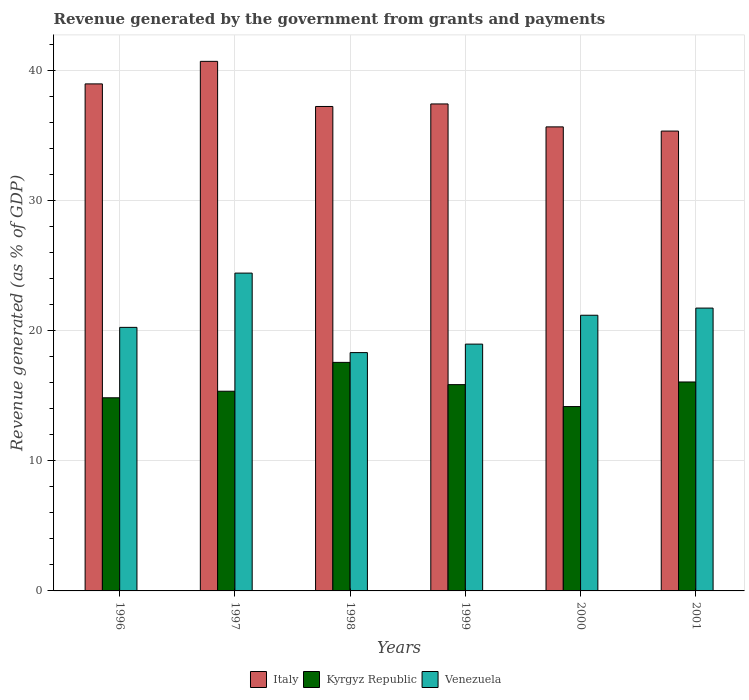How many groups of bars are there?
Your answer should be compact. 6. Are the number of bars per tick equal to the number of legend labels?
Give a very brief answer. Yes. Are the number of bars on each tick of the X-axis equal?
Keep it short and to the point. Yes. How many bars are there on the 3rd tick from the left?
Your response must be concise. 3. How many bars are there on the 4th tick from the right?
Keep it short and to the point. 3. In how many cases, is the number of bars for a given year not equal to the number of legend labels?
Your answer should be compact. 0. What is the revenue generated by the government in Venezuela in 1999?
Your answer should be compact. 18.96. Across all years, what is the maximum revenue generated by the government in Kyrgyz Republic?
Give a very brief answer. 17.56. Across all years, what is the minimum revenue generated by the government in Venezuela?
Your answer should be compact. 18.31. In which year was the revenue generated by the government in Kyrgyz Republic maximum?
Your answer should be compact. 1998. In which year was the revenue generated by the government in Italy minimum?
Offer a terse response. 2001. What is the total revenue generated by the government in Italy in the graph?
Give a very brief answer. 225.24. What is the difference between the revenue generated by the government in Venezuela in 2000 and that in 2001?
Make the answer very short. -0.55. What is the difference between the revenue generated by the government in Venezuela in 2000 and the revenue generated by the government in Italy in 1997?
Your response must be concise. -19.51. What is the average revenue generated by the government in Italy per year?
Provide a short and direct response. 37.54. In the year 2001, what is the difference between the revenue generated by the government in Kyrgyz Republic and revenue generated by the government in Venezuela?
Offer a terse response. -5.68. In how many years, is the revenue generated by the government in Venezuela greater than 6 %?
Give a very brief answer. 6. What is the ratio of the revenue generated by the government in Venezuela in 1997 to that in 2001?
Offer a terse response. 1.12. Is the revenue generated by the government in Venezuela in 1999 less than that in 2000?
Make the answer very short. Yes. Is the difference between the revenue generated by the government in Kyrgyz Republic in 1999 and 2001 greater than the difference between the revenue generated by the government in Venezuela in 1999 and 2001?
Keep it short and to the point. Yes. What is the difference between the highest and the second highest revenue generated by the government in Venezuela?
Give a very brief answer. 2.69. What is the difference between the highest and the lowest revenue generated by the government in Venezuela?
Make the answer very short. 6.11. In how many years, is the revenue generated by the government in Kyrgyz Republic greater than the average revenue generated by the government in Kyrgyz Republic taken over all years?
Provide a succinct answer. 3. What does the 3rd bar from the left in 2001 represents?
Your answer should be very brief. Venezuela. What does the 3rd bar from the right in 1996 represents?
Make the answer very short. Italy. Is it the case that in every year, the sum of the revenue generated by the government in Venezuela and revenue generated by the government in Kyrgyz Republic is greater than the revenue generated by the government in Italy?
Your answer should be compact. No. How many bars are there?
Offer a very short reply. 18. Are all the bars in the graph horizontal?
Give a very brief answer. No. How many years are there in the graph?
Offer a terse response. 6. Are the values on the major ticks of Y-axis written in scientific E-notation?
Ensure brevity in your answer.  No. Does the graph contain grids?
Give a very brief answer. Yes. How many legend labels are there?
Keep it short and to the point. 3. What is the title of the graph?
Your response must be concise. Revenue generated by the government from grants and payments. Does "Other small states" appear as one of the legend labels in the graph?
Your response must be concise. No. What is the label or title of the Y-axis?
Provide a succinct answer. Revenue generated (as % of GDP). What is the Revenue generated (as % of GDP) in Italy in 1996?
Keep it short and to the point. 38.95. What is the Revenue generated (as % of GDP) of Kyrgyz Republic in 1996?
Provide a short and direct response. 14.84. What is the Revenue generated (as % of GDP) in Venezuela in 1996?
Ensure brevity in your answer.  20.25. What is the Revenue generated (as % of GDP) of Italy in 1997?
Keep it short and to the point. 40.68. What is the Revenue generated (as % of GDP) in Kyrgyz Republic in 1997?
Provide a succinct answer. 15.34. What is the Revenue generated (as % of GDP) of Venezuela in 1997?
Provide a short and direct response. 24.42. What is the Revenue generated (as % of GDP) of Italy in 1998?
Offer a very short reply. 37.22. What is the Revenue generated (as % of GDP) of Kyrgyz Republic in 1998?
Ensure brevity in your answer.  17.56. What is the Revenue generated (as % of GDP) in Venezuela in 1998?
Offer a terse response. 18.31. What is the Revenue generated (as % of GDP) in Italy in 1999?
Provide a succinct answer. 37.41. What is the Revenue generated (as % of GDP) in Kyrgyz Republic in 1999?
Keep it short and to the point. 15.85. What is the Revenue generated (as % of GDP) of Venezuela in 1999?
Offer a very short reply. 18.96. What is the Revenue generated (as % of GDP) of Italy in 2000?
Give a very brief answer. 35.65. What is the Revenue generated (as % of GDP) in Kyrgyz Republic in 2000?
Your response must be concise. 14.16. What is the Revenue generated (as % of GDP) of Venezuela in 2000?
Provide a short and direct response. 21.18. What is the Revenue generated (as % of GDP) of Italy in 2001?
Make the answer very short. 35.33. What is the Revenue generated (as % of GDP) of Kyrgyz Republic in 2001?
Keep it short and to the point. 16.05. What is the Revenue generated (as % of GDP) of Venezuela in 2001?
Provide a short and direct response. 21.73. Across all years, what is the maximum Revenue generated (as % of GDP) of Italy?
Offer a terse response. 40.68. Across all years, what is the maximum Revenue generated (as % of GDP) of Kyrgyz Republic?
Your response must be concise. 17.56. Across all years, what is the maximum Revenue generated (as % of GDP) in Venezuela?
Ensure brevity in your answer.  24.42. Across all years, what is the minimum Revenue generated (as % of GDP) in Italy?
Offer a terse response. 35.33. Across all years, what is the minimum Revenue generated (as % of GDP) of Kyrgyz Republic?
Offer a terse response. 14.16. Across all years, what is the minimum Revenue generated (as % of GDP) in Venezuela?
Your answer should be compact. 18.31. What is the total Revenue generated (as % of GDP) in Italy in the graph?
Your response must be concise. 225.24. What is the total Revenue generated (as % of GDP) in Kyrgyz Republic in the graph?
Provide a succinct answer. 93.8. What is the total Revenue generated (as % of GDP) of Venezuela in the graph?
Your answer should be compact. 124.84. What is the difference between the Revenue generated (as % of GDP) of Italy in 1996 and that in 1997?
Provide a short and direct response. -1.73. What is the difference between the Revenue generated (as % of GDP) of Kyrgyz Republic in 1996 and that in 1997?
Offer a very short reply. -0.5. What is the difference between the Revenue generated (as % of GDP) of Venezuela in 1996 and that in 1997?
Provide a short and direct response. -4.17. What is the difference between the Revenue generated (as % of GDP) of Italy in 1996 and that in 1998?
Provide a short and direct response. 1.73. What is the difference between the Revenue generated (as % of GDP) in Kyrgyz Republic in 1996 and that in 1998?
Your answer should be very brief. -2.72. What is the difference between the Revenue generated (as % of GDP) in Venezuela in 1996 and that in 1998?
Give a very brief answer. 1.94. What is the difference between the Revenue generated (as % of GDP) in Italy in 1996 and that in 1999?
Make the answer very short. 1.54. What is the difference between the Revenue generated (as % of GDP) in Kyrgyz Republic in 1996 and that in 1999?
Your answer should be very brief. -1.01. What is the difference between the Revenue generated (as % of GDP) of Venezuela in 1996 and that in 1999?
Provide a succinct answer. 1.29. What is the difference between the Revenue generated (as % of GDP) of Italy in 1996 and that in 2000?
Provide a short and direct response. 3.3. What is the difference between the Revenue generated (as % of GDP) in Kyrgyz Republic in 1996 and that in 2000?
Offer a terse response. 0.67. What is the difference between the Revenue generated (as % of GDP) in Venezuela in 1996 and that in 2000?
Your answer should be compact. -0.93. What is the difference between the Revenue generated (as % of GDP) of Italy in 1996 and that in 2001?
Your answer should be compact. 3.62. What is the difference between the Revenue generated (as % of GDP) in Kyrgyz Republic in 1996 and that in 2001?
Give a very brief answer. -1.22. What is the difference between the Revenue generated (as % of GDP) in Venezuela in 1996 and that in 2001?
Give a very brief answer. -1.48. What is the difference between the Revenue generated (as % of GDP) of Italy in 1997 and that in 1998?
Offer a very short reply. 3.47. What is the difference between the Revenue generated (as % of GDP) of Kyrgyz Republic in 1997 and that in 1998?
Your answer should be very brief. -2.22. What is the difference between the Revenue generated (as % of GDP) of Venezuela in 1997 and that in 1998?
Ensure brevity in your answer.  6.11. What is the difference between the Revenue generated (as % of GDP) of Italy in 1997 and that in 1999?
Your answer should be compact. 3.27. What is the difference between the Revenue generated (as % of GDP) in Kyrgyz Republic in 1997 and that in 1999?
Give a very brief answer. -0.51. What is the difference between the Revenue generated (as % of GDP) of Venezuela in 1997 and that in 1999?
Your answer should be compact. 5.46. What is the difference between the Revenue generated (as % of GDP) of Italy in 1997 and that in 2000?
Make the answer very short. 5.03. What is the difference between the Revenue generated (as % of GDP) of Kyrgyz Republic in 1997 and that in 2000?
Ensure brevity in your answer.  1.18. What is the difference between the Revenue generated (as % of GDP) of Venezuela in 1997 and that in 2000?
Make the answer very short. 3.24. What is the difference between the Revenue generated (as % of GDP) in Italy in 1997 and that in 2001?
Offer a terse response. 5.36. What is the difference between the Revenue generated (as % of GDP) in Kyrgyz Republic in 1997 and that in 2001?
Provide a short and direct response. -0.71. What is the difference between the Revenue generated (as % of GDP) of Venezuela in 1997 and that in 2001?
Give a very brief answer. 2.69. What is the difference between the Revenue generated (as % of GDP) of Italy in 1998 and that in 1999?
Keep it short and to the point. -0.19. What is the difference between the Revenue generated (as % of GDP) in Kyrgyz Republic in 1998 and that in 1999?
Give a very brief answer. 1.71. What is the difference between the Revenue generated (as % of GDP) in Venezuela in 1998 and that in 1999?
Ensure brevity in your answer.  -0.65. What is the difference between the Revenue generated (as % of GDP) in Italy in 1998 and that in 2000?
Provide a succinct answer. 1.57. What is the difference between the Revenue generated (as % of GDP) in Kyrgyz Republic in 1998 and that in 2000?
Keep it short and to the point. 3.39. What is the difference between the Revenue generated (as % of GDP) in Venezuela in 1998 and that in 2000?
Provide a short and direct response. -2.87. What is the difference between the Revenue generated (as % of GDP) of Italy in 1998 and that in 2001?
Provide a succinct answer. 1.89. What is the difference between the Revenue generated (as % of GDP) in Kyrgyz Republic in 1998 and that in 2001?
Keep it short and to the point. 1.5. What is the difference between the Revenue generated (as % of GDP) of Venezuela in 1998 and that in 2001?
Keep it short and to the point. -3.42. What is the difference between the Revenue generated (as % of GDP) in Italy in 1999 and that in 2000?
Give a very brief answer. 1.76. What is the difference between the Revenue generated (as % of GDP) of Kyrgyz Republic in 1999 and that in 2000?
Ensure brevity in your answer.  1.69. What is the difference between the Revenue generated (as % of GDP) in Venezuela in 1999 and that in 2000?
Your answer should be compact. -2.22. What is the difference between the Revenue generated (as % of GDP) in Italy in 1999 and that in 2001?
Keep it short and to the point. 2.08. What is the difference between the Revenue generated (as % of GDP) of Kyrgyz Republic in 1999 and that in 2001?
Offer a terse response. -0.2. What is the difference between the Revenue generated (as % of GDP) of Venezuela in 1999 and that in 2001?
Ensure brevity in your answer.  -2.77. What is the difference between the Revenue generated (as % of GDP) of Italy in 2000 and that in 2001?
Your answer should be compact. 0.32. What is the difference between the Revenue generated (as % of GDP) in Kyrgyz Republic in 2000 and that in 2001?
Ensure brevity in your answer.  -1.89. What is the difference between the Revenue generated (as % of GDP) of Venezuela in 2000 and that in 2001?
Your answer should be very brief. -0.55. What is the difference between the Revenue generated (as % of GDP) in Italy in 1996 and the Revenue generated (as % of GDP) in Kyrgyz Republic in 1997?
Ensure brevity in your answer.  23.61. What is the difference between the Revenue generated (as % of GDP) in Italy in 1996 and the Revenue generated (as % of GDP) in Venezuela in 1997?
Give a very brief answer. 14.54. What is the difference between the Revenue generated (as % of GDP) in Kyrgyz Republic in 1996 and the Revenue generated (as % of GDP) in Venezuela in 1997?
Your answer should be very brief. -9.58. What is the difference between the Revenue generated (as % of GDP) of Italy in 1996 and the Revenue generated (as % of GDP) of Kyrgyz Republic in 1998?
Provide a succinct answer. 21.4. What is the difference between the Revenue generated (as % of GDP) in Italy in 1996 and the Revenue generated (as % of GDP) in Venezuela in 1998?
Offer a very short reply. 20.64. What is the difference between the Revenue generated (as % of GDP) of Kyrgyz Republic in 1996 and the Revenue generated (as % of GDP) of Venezuela in 1998?
Offer a terse response. -3.47. What is the difference between the Revenue generated (as % of GDP) of Italy in 1996 and the Revenue generated (as % of GDP) of Kyrgyz Republic in 1999?
Your answer should be very brief. 23.1. What is the difference between the Revenue generated (as % of GDP) in Italy in 1996 and the Revenue generated (as % of GDP) in Venezuela in 1999?
Provide a short and direct response. 19.99. What is the difference between the Revenue generated (as % of GDP) in Kyrgyz Republic in 1996 and the Revenue generated (as % of GDP) in Venezuela in 1999?
Make the answer very short. -4.12. What is the difference between the Revenue generated (as % of GDP) of Italy in 1996 and the Revenue generated (as % of GDP) of Kyrgyz Republic in 2000?
Offer a terse response. 24.79. What is the difference between the Revenue generated (as % of GDP) in Italy in 1996 and the Revenue generated (as % of GDP) in Venezuela in 2000?
Make the answer very short. 17.77. What is the difference between the Revenue generated (as % of GDP) of Kyrgyz Republic in 1996 and the Revenue generated (as % of GDP) of Venezuela in 2000?
Ensure brevity in your answer.  -6.34. What is the difference between the Revenue generated (as % of GDP) in Italy in 1996 and the Revenue generated (as % of GDP) in Kyrgyz Republic in 2001?
Your response must be concise. 22.9. What is the difference between the Revenue generated (as % of GDP) in Italy in 1996 and the Revenue generated (as % of GDP) in Venezuela in 2001?
Keep it short and to the point. 17.22. What is the difference between the Revenue generated (as % of GDP) in Kyrgyz Republic in 1996 and the Revenue generated (as % of GDP) in Venezuela in 2001?
Ensure brevity in your answer.  -6.89. What is the difference between the Revenue generated (as % of GDP) in Italy in 1997 and the Revenue generated (as % of GDP) in Kyrgyz Republic in 1998?
Make the answer very short. 23.13. What is the difference between the Revenue generated (as % of GDP) in Italy in 1997 and the Revenue generated (as % of GDP) in Venezuela in 1998?
Provide a short and direct response. 22.37. What is the difference between the Revenue generated (as % of GDP) of Kyrgyz Republic in 1997 and the Revenue generated (as % of GDP) of Venezuela in 1998?
Provide a short and direct response. -2.97. What is the difference between the Revenue generated (as % of GDP) in Italy in 1997 and the Revenue generated (as % of GDP) in Kyrgyz Republic in 1999?
Provide a short and direct response. 24.84. What is the difference between the Revenue generated (as % of GDP) in Italy in 1997 and the Revenue generated (as % of GDP) in Venezuela in 1999?
Your answer should be very brief. 21.72. What is the difference between the Revenue generated (as % of GDP) of Kyrgyz Republic in 1997 and the Revenue generated (as % of GDP) of Venezuela in 1999?
Offer a very short reply. -3.62. What is the difference between the Revenue generated (as % of GDP) of Italy in 1997 and the Revenue generated (as % of GDP) of Kyrgyz Republic in 2000?
Your response must be concise. 26.52. What is the difference between the Revenue generated (as % of GDP) of Italy in 1997 and the Revenue generated (as % of GDP) of Venezuela in 2000?
Your response must be concise. 19.51. What is the difference between the Revenue generated (as % of GDP) in Kyrgyz Republic in 1997 and the Revenue generated (as % of GDP) in Venezuela in 2000?
Ensure brevity in your answer.  -5.84. What is the difference between the Revenue generated (as % of GDP) in Italy in 1997 and the Revenue generated (as % of GDP) in Kyrgyz Republic in 2001?
Provide a short and direct response. 24.63. What is the difference between the Revenue generated (as % of GDP) of Italy in 1997 and the Revenue generated (as % of GDP) of Venezuela in 2001?
Give a very brief answer. 18.96. What is the difference between the Revenue generated (as % of GDP) of Kyrgyz Republic in 1997 and the Revenue generated (as % of GDP) of Venezuela in 2001?
Make the answer very short. -6.39. What is the difference between the Revenue generated (as % of GDP) in Italy in 1998 and the Revenue generated (as % of GDP) in Kyrgyz Republic in 1999?
Your answer should be compact. 21.37. What is the difference between the Revenue generated (as % of GDP) in Italy in 1998 and the Revenue generated (as % of GDP) in Venezuela in 1999?
Make the answer very short. 18.26. What is the difference between the Revenue generated (as % of GDP) of Kyrgyz Republic in 1998 and the Revenue generated (as % of GDP) of Venezuela in 1999?
Your response must be concise. -1.4. What is the difference between the Revenue generated (as % of GDP) in Italy in 1998 and the Revenue generated (as % of GDP) in Kyrgyz Republic in 2000?
Your response must be concise. 23.05. What is the difference between the Revenue generated (as % of GDP) in Italy in 1998 and the Revenue generated (as % of GDP) in Venezuela in 2000?
Keep it short and to the point. 16.04. What is the difference between the Revenue generated (as % of GDP) in Kyrgyz Republic in 1998 and the Revenue generated (as % of GDP) in Venezuela in 2000?
Offer a terse response. -3.62. What is the difference between the Revenue generated (as % of GDP) of Italy in 1998 and the Revenue generated (as % of GDP) of Kyrgyz Republic in 2001?
Your response must be concise. 21.16. What is the difference between the Revenue generated (as % of GDP) in Italy in 1998 and the Revenue generated (as % of GDP) in Venezuela in 2001?
Give a very brief answer. 15.49. What is the difference between the Revenue generated (as % of GDP) in Kyrgyz Republic in 1998 and the Revenue generated (as % of GDP) in Venezuela in 2001?
Give a very brief answer. -4.17. What is the difference between the Revenue generated (as % of GDP) of Italy in 1999 and the Revenue generated (as % of GDP) of Kyrgyz Republic in 2000?
Make the answer very short. 23.25. What is the difference between the Revenue generated (as % of GDP) in Italy in 1999 and the Revenue generated (as % of GDP) in Venezuela in 2000?
Your response must be concise. 16.23. What is the difference between the Revenue generated (as % of GDP) of Kyrgyz Republic in 1999 and the Revenue generated (as % of GDP) of Venezuela in 2000?
Ensure brevity in your answer.  -5.33. What is the difference between the Revenue generated (as % of GDP) in Italy in 1999 and the Revenue generated (as % of GDP) in Kyrgyz Republic in 2001?
Your answer should be very brief. 21.36. What is the difference between the Revenue generated (as % of GDP) of Italy in 1999 and the Revenue generated (as % of GDP) of Venezuela in 2001?
Offer a very short reply. 15.68. What is the difference between the Revenue generated (as % of GDP) in Kyrgyz Republic in 1999 and the Revenue generated (as % of GDP) in Venezuela in 2001?
Keep it short and to the point. -5.88. What is the difference between the Revenue generated (as % of GDP) in Italy in 2000 and the Revenue generated (as % of GDP) in Kyrgyz Republic in 2001?
Offer a very short reply. 19.6. What is the difference between the Revenue generated (as % of GDP) in Italy in 2000 and the Revenue generated (as % of GDP) in Venezuela in 2001?
Your answer should be compact. 13.92. What is the difference between the Revenue generated (as % of GDP) of Kyrgyz Republic in 2000 and the Revenue generated (as % of GDP) of Venezuela in 2001?
Give a very brief answer. -7.57. What is the average Revenue generated (as % of GDP) of Italy per year?
Your answer should be very brief. 37.54. What is the average Revenue generated (as % of GDP) in Kyrgyz Republic per year?
Provide a succinct answer. 15.63. What is the average Revenue generated (as % of GDP) of Venezuela per year?
Offer a very short reply. 20.81. In the year 1996, what is the difference between the Revenue generated (as % of GDP) in Italy and Revenue generated (as % of GDP) in Kyrgyz Republic?
Give a very brief answer. 24.11. In the year 1996, what is the difference between the Revenue generated (as % of GDP) of Italy and Revenue generated (as % of GDP) of Venezuela?
Your answer should be compact. 18.7. In the year 1996, what is the difference between the Revenue generated (as % of GDP) of Kyrgyz Republic and Revenue generated (as % of GDP) of Venezuela?
Keep it short and to the point. -5.41. In the year 1997, what is the difference between the Revenue generated (as % of GDP) of Italy and Revenue generated (as % of GDP) of Kyrgyz Republic?
Keep it short and to the point. 25.34. In the year 1997, what is the difference between the Revenue generated (as % of GDP) of Italy and Revenue generated (as % of GDP) of Venezuela?
Your answer should be compact. 16.27. In the year 1997, what is the difference between the Revenue generated (as % of GDP) of Kyrgyz Republic and Revenue generated (as % of GDP) of Venezuela?
Give a very brief answer. -9.07. In the year 1998, what is the difference between the Revenue generated (as % of GDP) in Italy and Revenue generated (as % of GDP) in Kyrgyz Republic?
Keep it short and to the point. 19.66. In the year 1998, what is the difference between the Revenue generated (as % of GDP) in Italy and Revenue generated (as % of GDP) in Venezuela?
Offer a terse response. 18.91. In the year 1998, what is the difference between the Revenue generated (as % of GDP) in Kyrgyz Republic and Revenue generated (as % of GDP) in Venezuela?
Your answer should be very brief. -0.75. In the year 1999, what is the difference between the Revenue generated (as % of GDP) in Italy and Revenue generated (as % of GDP) in Kyrgyz Republic?
Make the answer very short. 21.56. In the year 1999, what is the difference between the Revenue generated (as % of GDP) of Italy and Revenue generated (as % of GDP) of Venezuela?
Ensure brevity in your answer.  18.45. In the year 1999, what is the difference between the Revenue generated (as % of GDP) of Kyrgyz Republic and Revenue generated (as % of GDP) of Venezuela?
Your response must be concise. -3.11. In the year 2000, what is the difference between the Revenue generated (as % of GDP) in Italy and Revenue generated (as % of GDP) in Kyrgyz Republic?
Provide a succinct answer. 21.49. In the year 2000, what is the difference between the Revenue generated (as % of GDP) in Italy and Revenue generated (as % of GDP) in Venezuela?
Provide a succinct answer. 14.47. In the year 2000, what is the difference between the Revenue generated (as % of GDP) in Kyrgyz Republic and Revenue generated (as % of GDP) in Venezuela?
Your answer should be compact. -7.02. In the year 2001, what is the difference between the Revenue generated (as % of GDP) in Italy and Revenue generated (as % of GDP) in Kyrgyz Republic?
Make the answer very short. 19.28. In the year 2001, what is the difference between the Revenue generated (as % of GDP) in Italy and Revenue generated (as % of GDP) in Venezuela?
Provide a short and direct response. 13.6. In the year 2001, what is the difference between the Revenue generated (as % of GDP) of Kyrgyz Republic and Revenue generated (as % of GDP) of Venezuela?
Ensure brevity in your answer.  -5.68. What is the ratio of the Revenue generated (as % of GDP) of Italy in 1996 to that in 1997?
Ensure brevity in your answer.  0.96. What is the ratio of the Revenue generated (as % of GDP) of Kyrgyz Republic in 1996 to that in 1997?
Ensure brevity in your answer.  0.97. What is the ratio of the Revenue generated (as % of GDP) of Venezuela in 1996 to that in 1997?
Your response must be concise. 0.83. What is the ratio of the Revenue generated (as % of GDP) in Italy in 1996 to that in 1998?
Your answer should be compact. 1.05. What is the ratio of the Revenue generated (as % of GDP) in Kyrgyz Republic in 1996 to that in 1998?
Offer a very short reply. 0.85. What is the ratio of the Revenue generated (as % of GDP) in Venezuela in 1996 to that in 1998?
Keep it short and to the point. 1.11. What is the ratio of the Revenue generated (as % of GDP) in Italy in 1996 to that in 1999?
Offer a terse response. 1.04. What is the ratio of the Revenue generated (as % of GDP) of Kyrgyz Republic in 1996 to that in 1999?
Provide a short and direct response. 0.94. What is the ratio of the Revenue generated (as % of GDP) of Venezuela in 1996 to that in 1999?
Your answer should be very brief. 1.07. What is the ratio of the Revenue generated (as % of GDP) of Italy in 1996 to that in 2000?
Offer a terse response. 1.09. What is the ratio of the Revenue generated (as % of GDP) in Kyrgyz Republic in 1996 to that in 2000?
Give a very brief answer. 1.05. What is the ratio of the Revenue generated (as % of GDP) of Venezuela in 1996 to that in 2000?
Your answer should be compact. 0.96. What is the ratio of the Revenue generated (as % of GDP) in Italy in 1996 to that in 2001?
Offer a terse response. 1.1. What is the ratio of the Revenue generated (as % of GDP) of Kyrgyz Republic in 1996 to that in 2001?
Ensure brevity in your answer.  0.92. What is the ratio of the Revenue generated (as % of GDP) in Venezuela in 1996 to that in 2001?
Ensure brevity in your answer.  0.93. What is the ratio of the Revenue generated (as % of GDP) of Italy in 1997 to that in 1998?
Provide a succinct answer. 1.09. What is the ratio of the Revenue generated (as % of GDP) in Kyrgyz Republic in 1997 to that in 1998?
Make the answer very short. 0.87. What is the ratio of the Revenue generated (as % of GDP) of Venezuela in 1997 to that in 1998?
Keep it short and to the point. 1.33. What is the ratio of the Revenue generated (as % of GDP) of Italy in 1997 to that in 1999?
Provide a succinct answer. 1.09. What is the ratio of the Revenue generated (as % of GDP) in Venezuela in 1997 to that in 1999?
Your response must be concise. 1.29. What is the ratio of the Revenue generated (as % of GDP) of Italy in 1997 to that in 2000?
Make the answer very short. 1.14. What is the ratio of the Revenue generated (as % of GDP) of Kyrgyz Republic in 1997 to that in 2000?
Provide a short and direct response. 1.08. What is the ratio of the Revenue generated (as % of GDP) in Venezuela in 1997 to that in 2000?
Ensure brevity in your answer.  1.15. What is the ratio of the Revenue generated (as % of GDP) in Italy in 1997 to that in 2001?
Your answer should be compact. 1.15. What is the ratio of the Revenue generated (as % of GDP) of Kyrgyz Republic in 1997 to that in 2001?
Your response must be concise. 0.96. What is the ratio of the Revenue generated (as % of GDP) in Venezuela in 1997 to that in 2001?
Your answer should be compact. 1.12. What is the ratio of the Revenue generated (as % of GDP) of Italy in 1998 to that in 1999?
Make the answer very short. 0.99. What is the ratio of the Revenue generated (as % of GDP) of Kyrgyz Republic in 1998 to that in 1999?
Your answer should be compact. 1.11. What is the ratio of the Revenue generated (as % of GDP) in Venezuela in 1998 to that in 1999?
Ensure brevity in your answer.  0.97. What is the ratio of the Revenue generated (as % of GDP) in Italy in 1998 to that in 2000?
Your response must be concise. 1.04. What is the ratio of the Revenue generated (as % of GDP) in Kyrgyz Republic in 1998 to that in 2000?
Your answer should be compact. 1.24. What is the ratio of the Revenue generated (as % of GDP) in Venezuela in 1998 to that in 2000?
Your response must be concise. 0.86. What is the ratio of the Revenue generated (as % of GDP) of Italy in 1998 to that in 2001?
Keep it short and to the point. 1.05. What is the ratio of the Revenue generated (as % of GDP) of Kyrgyz Republic in 1998 to that in 2001?
Keep it short and to the point. 1.09. What is the ratio of the Revenue generated (as % of GDP) of Venezuela in 1998 to that in 2001?
Give a very brief answer. 0.84. What is the ratio of the Revenue generated (as % of GDP) of Italy in 1999 to that in 2000?
Give a very brief answer. 1.05. What is the ratio of the Revenue generated (as % of GDP) of Kyrgyz Republic in 1999 to that in 2000?
Provide a short and direct response. 1.12. What is the ratio of the Revenue generated (as % of GDP) in Venezuela in 1999 to that in 2000?
Provide a succinct answer. 0.9. What is the ratio of the Revenue generated (as % of GDP) in Italy in 1999 to that in 2001?
Offer a terse response. 1.06. What is the ratio of the Revenue generated (as % of GDP) of Kyrgyz Republic in 1999 to that in 2001?
Your answer should be very brief. 0.99. What is the ratio of the Revenue generated (as % of GDP) in Venezuela in 1999 to that in 2001?
Give a very brief answer. 0.87. What is the ratio of the Revenue generated (as % of GDP) in Italy in 2000 to that in 2001?
Keep it short and to the point. 1.01. What is the ratio of the Revenue generated (as % of GDP) of Kyrgyz Republic in 2000 to that in 2001?
Offer a terse response. 0.88. What is the ratio of the Revenue generated (as % of GDP) in Venezuela in 2000 to that in 2001?
Make the answer very short. 0.97. What is the difference between the highest and the second highest Revenue generated (as % of GDP) of Italy?
Keep it short and to the point. 1.73. What is the difference between the highest and the second highest Revenue generated (as % of GDP) of Kyrgyz Republic?
Your answer should be very brief. 1.5. What is the difference between the highest and the second highest Revenue generated (as % of GDP) in Venezuela?
Ensure brevity in your answer.  2.69. What is the difference between the highest and the lowest Revenue generated (as % of GDP) in Italy?
Ensure brevity in your answer.  5.36. What is the difference between the highest and the lowest Revenue generated (as % of GDP) of Kyrgyz Republic?
Keep it short and to the point. 3.39. What is the difference between the highest and the lowest Revenue generated (as % of GDP) in Venezuela?
Your response must be concise. 6.11. 